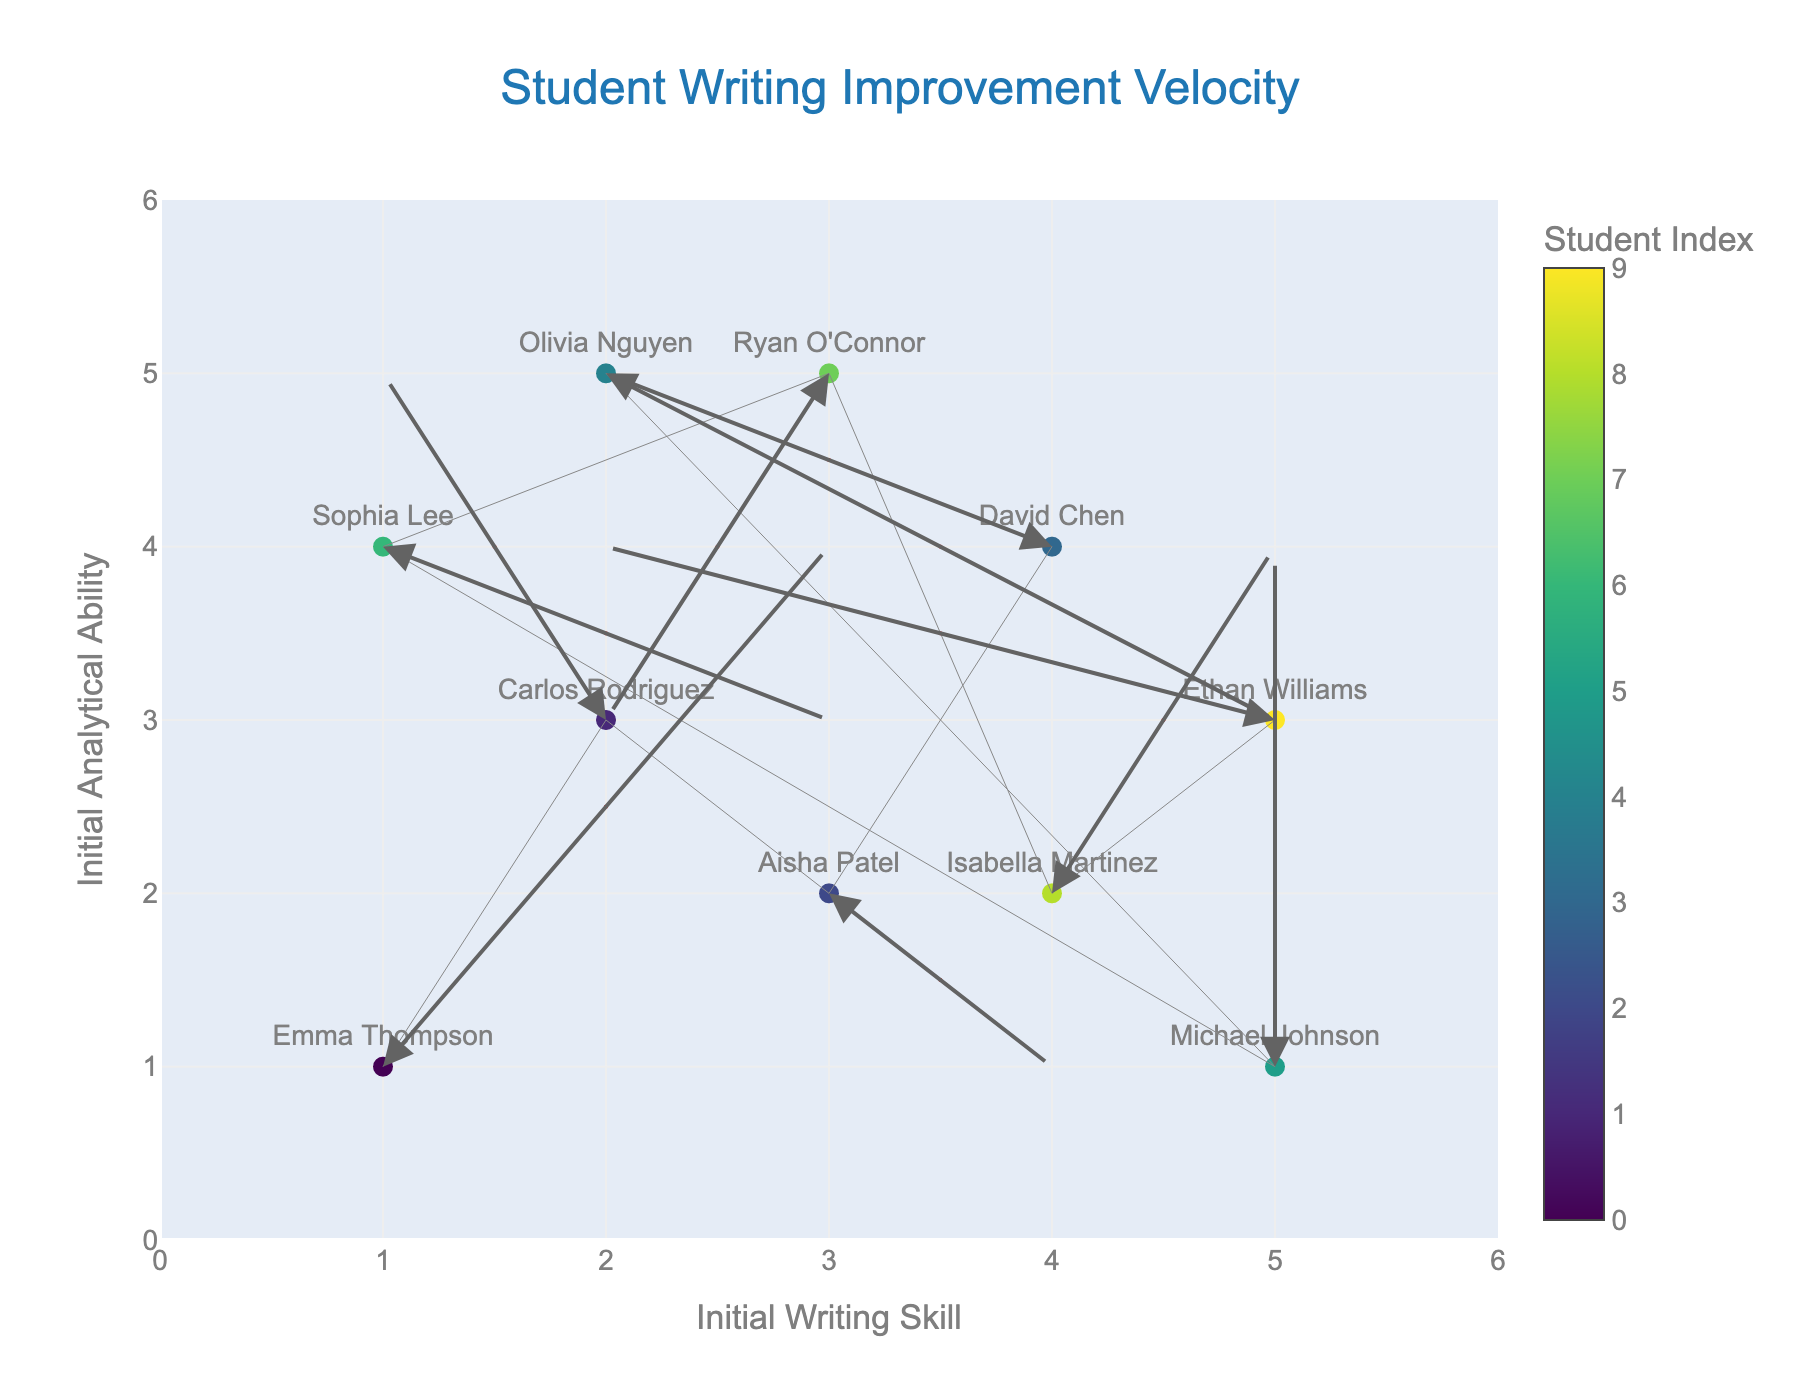What is the title of the plot? The title of the plot is displayed at the top center of the plot area. It helps in understanding what the plot is depicting.
Answer: Student Writing Improvement Velocity How many students are shown in the plot? By observing the number of markers with student names on the plot, we can count the distinct students.
Answer: 10 Which student's writing skill and analytical ability shows the largest improvement in positive x and y direction combined? To find the largest combined improvement, we look for the student with the longest arrow pointing in the positive x (u) and y (v) direction. Emma Thompson's arrow is the longest and points in both positive x and y directions.
Answer: Emma Thompson What is the initial position of David Chen? The initial position is represented by his marker on the plot. It is the point before the arrow starts.
Answer: (4,4) Which student had the largest decrease in analytical ability? To find this, we look for the student with the arrow having the largest negative y-component (v). Aisha Patel's arrow has a large downward component, indicating a decrease.
Answer: Aisha Patel How many students' improvements include a positive change in analytical ability (y-direction)? By counting the number of arrows with a positive y-component (v) direction, we find the students with improvement in analytical ability.
Answer: 6 What is the overall direction of improvement for Carlos Rodriguez? The direction of improvement is indicated by the arrow from his initial position. Carlos Rodriguez's arrow points right and slightly up, showing improvement in both skills.
Answer: Right and slightly up Which student starts at the same initial writing skill level as Olivia Nguyen but shows improvement in different directions? In the plot, both Olivia Nguyen and Carlos Rodriguez start at an x-coordinate of 2, but their arrows point in different directions.
Answer: Carlos Rodriguez What are the ending coordinates of Michael Johnson's improvement? To find the ending coordinates, add Michael Johnson's initial position (5,1) to his improvement vector (0,3). The ending coordinates are (5, 4).
Answer: (5,4) Compare the direction of improvement between Sophia Lee and Ryan O'Connor. Who has improved more in the writing skill (x-direction)? Compare the x-components (u) of Sophia Lee (u=2) and Ryan O'Connor (u=-1). Sophia Lee's arrow points more to the right, indicating a larger improvement in writing skill.
Answer: Sophia Lee 